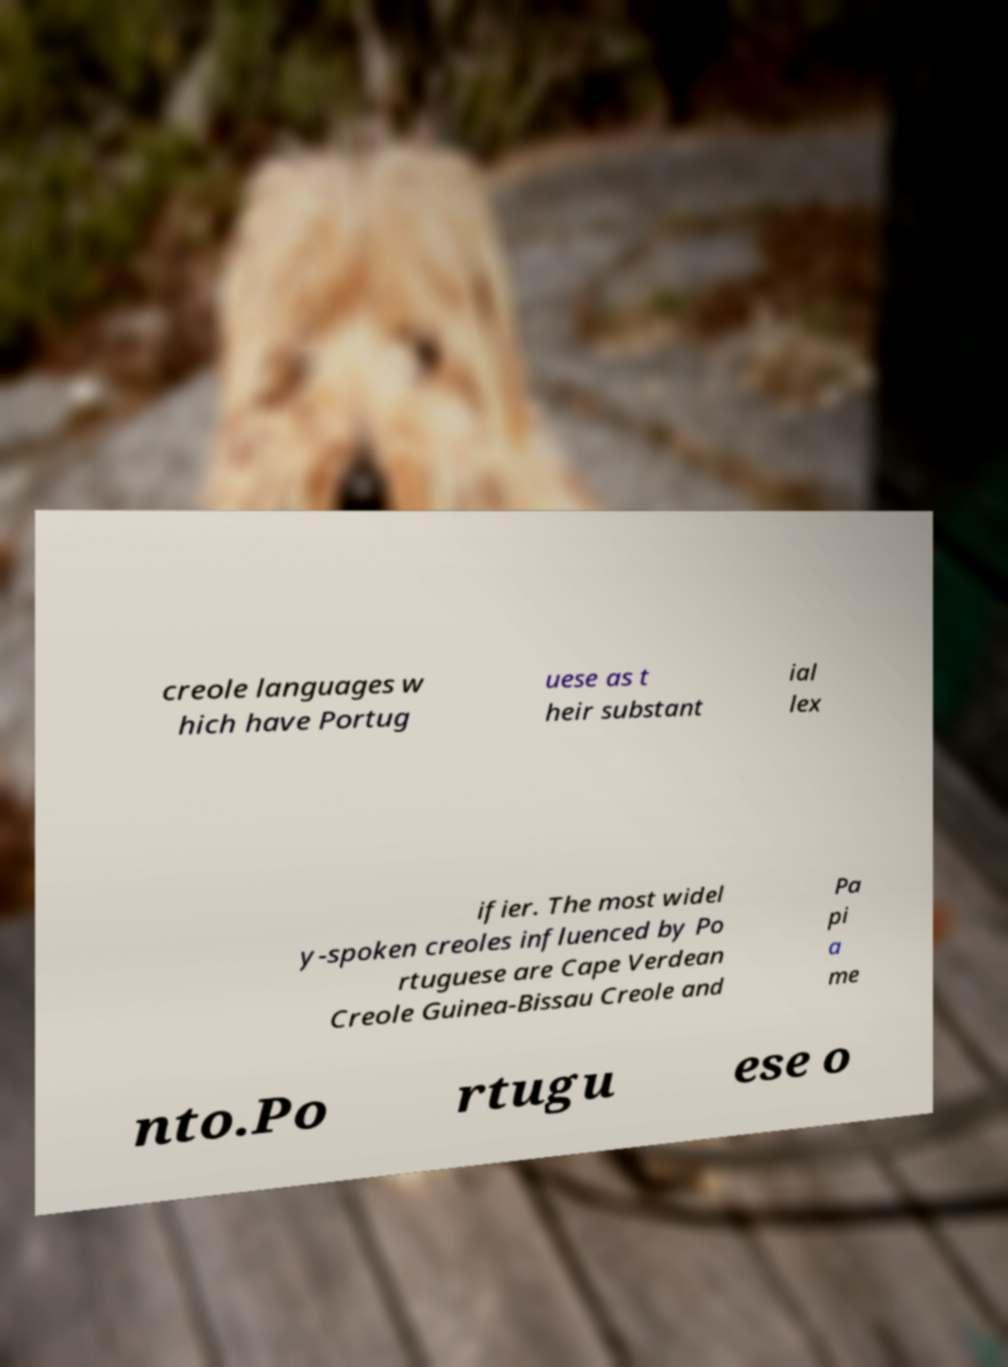What messages or text are displayed in this image? I need them in a readable, typed format. creole languages w hich have Portug uese as t heir substant ial lex ifier. The most widel y-spoken creoles influenced by Po rtuguese are Cape Verdean Creole Guinea-Bissau Creole and Pa pi a me nto.Po rtugu ese o 